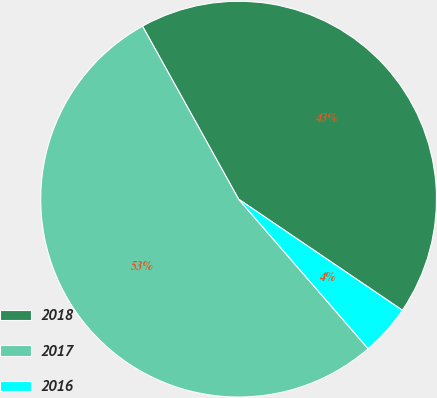Convert chart to OTSL. <chart><loc_0><loc_0><loc_500><loc_500><pie_chart><fcel>2018<fcel>2017<fcel>2016<nl><fcel>42.56%<fcel>53.29%<fcel>4.15%<nl></chart> 